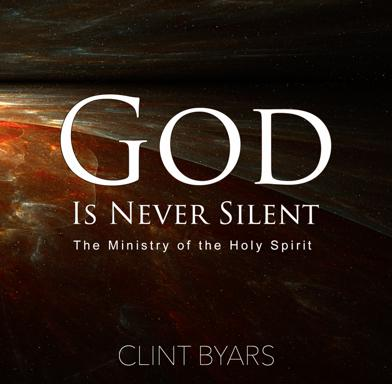What is the title and author of the book mentioned in the image? The image displays the book titled 'God Is Never Silent: The Ministry of the Holy Spirit' by Clint Byars. This book delves into the continuous, dynamic presence of the Holy Spirit in the lives of believers, emphasizing that God communicates and acts through the Holy Spirit perpetually. 